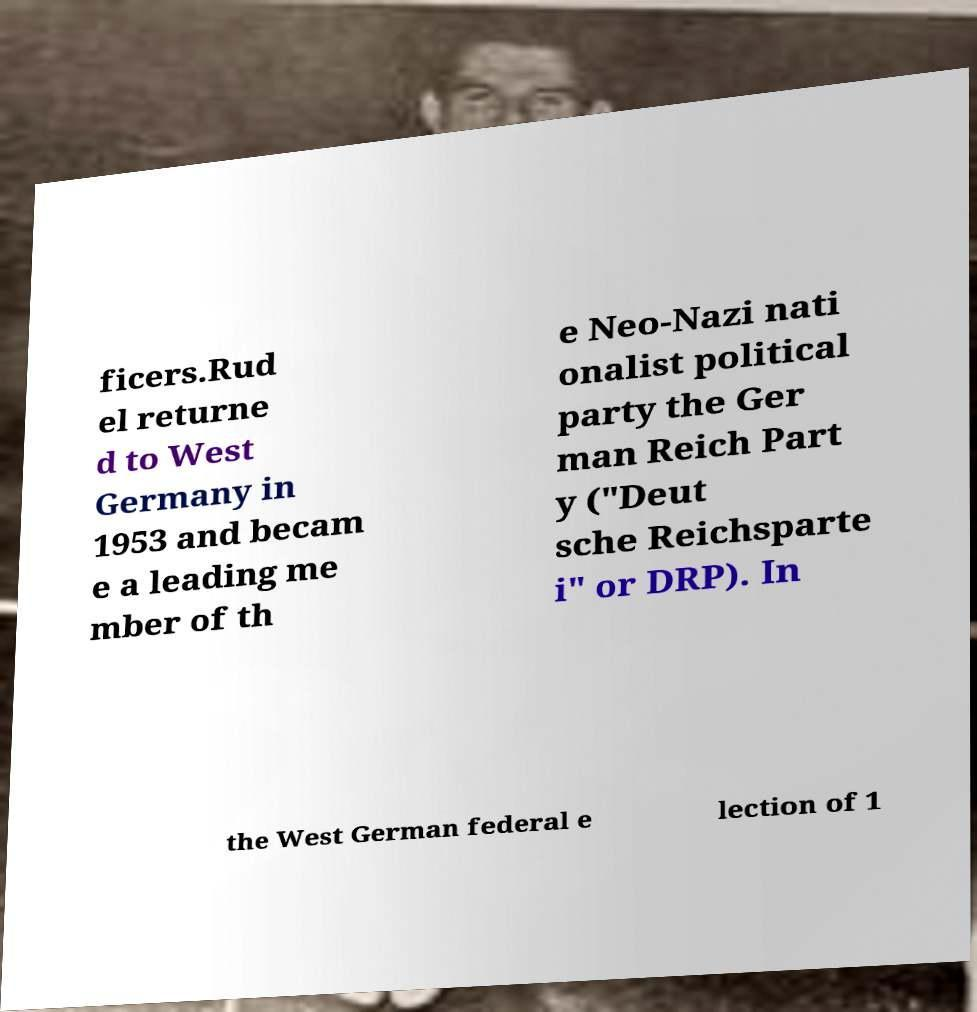Could you extract and type out the text from this image? ficers.Rud el returne d to West Germany in 1953 and becam e a leading me mber of th e Neo-Nazi nati onalist political party the Ger man Reich Part y ("Deut sche Reichsparte i" or DRP). In the West German federal e lection of 1 